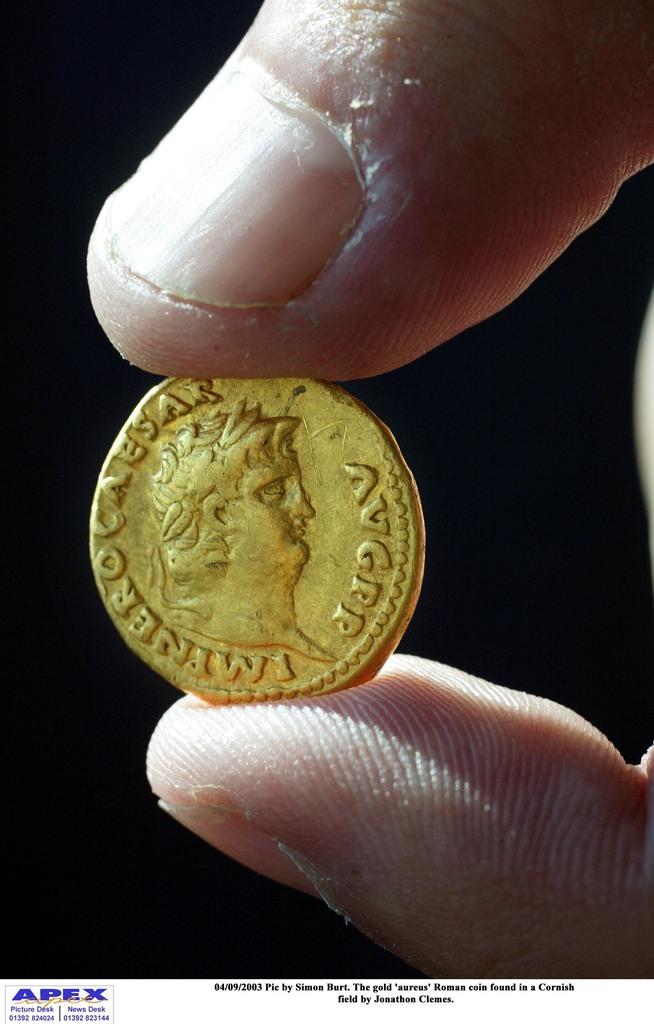What is the company name in the logo on the bottom left?
Your answer should be very brief. Apex. What is engrabed on the coin?
Ensure brevity in your answer.  Unanswerable. 